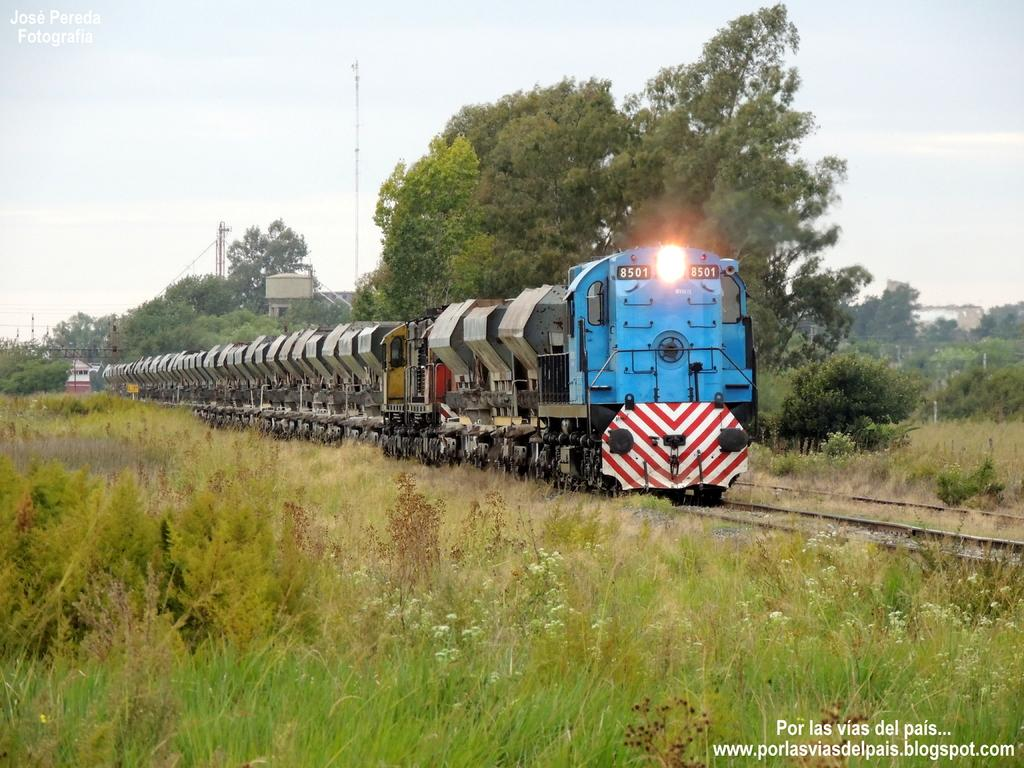What is the main subject of the image? The main subject of the image is a train. Where is the train located in the image? The train is on a track in the image. What can be seen in the background of the image? There is a lot of greenery around the train in the image. What letter is written on the side of the train in the image? There is no letter written on the side of the train in the image. Can you see a monkey riding on top of the train in the image? There is no monkey present in the image. 